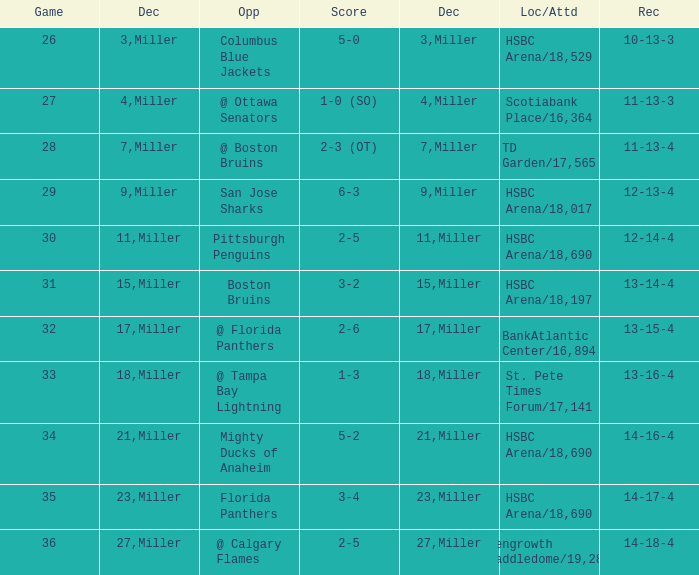Name the score for 29 game 6-3. 